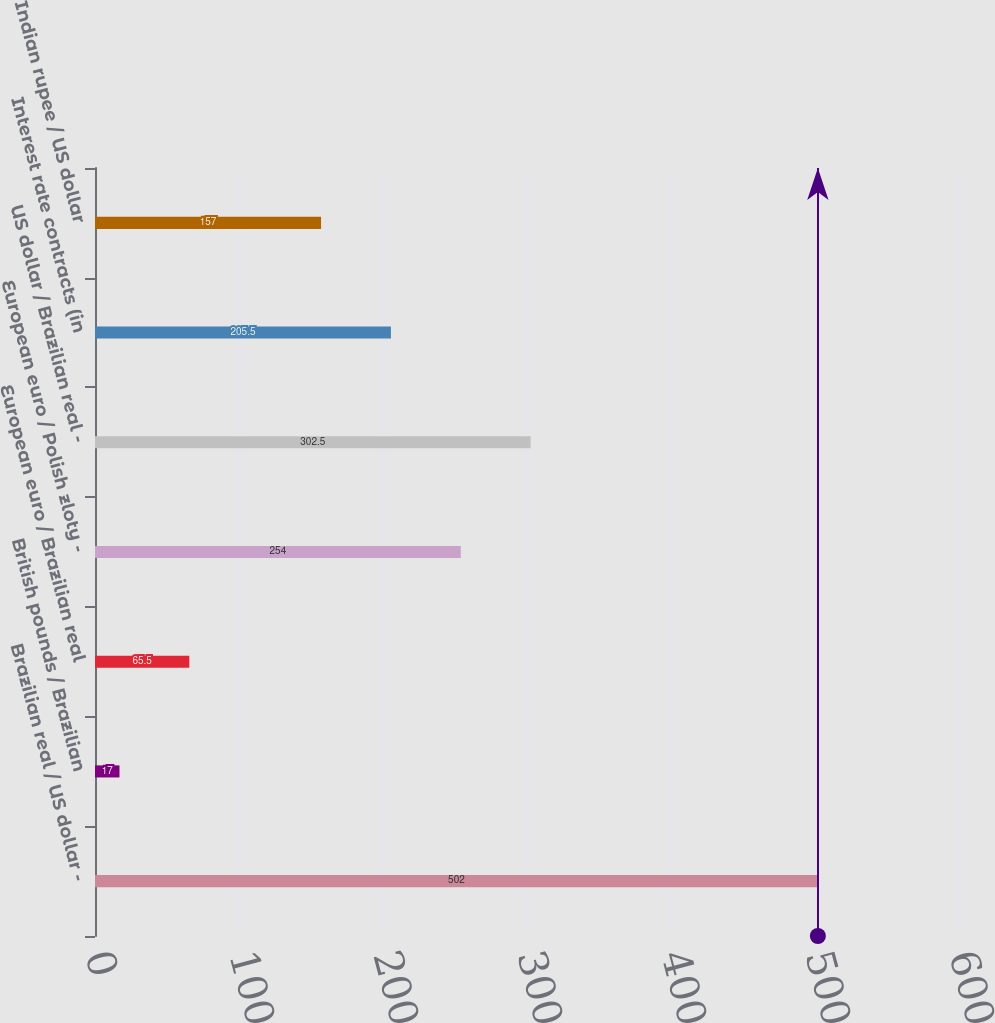Convert chart to OTSL. <chart><loc_0><loc_0><loc_500><loc_500><bar_chart><fcel>Brazilian real / US dollar -<fcel>British pounds / Brazilian<fcel>European euro / Brazilian real<fcel>European euro / Polish zloty -<fcel>US dollar / Brazilian real -<fcel>Interest rate contracts (in<fcel>Indian rupee / US dollar<nl><fcel>502<fcel>17<fcel>65.5<fcel>254<fcel>302.5<fcel>205.5<fcel>157<nl></chart> 